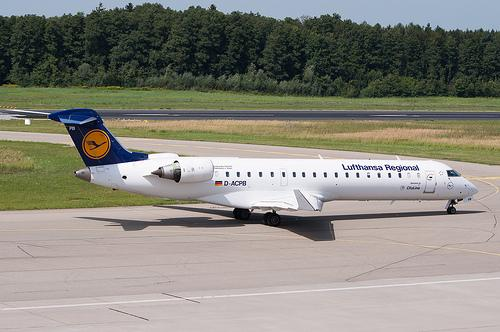Using descriptive language, explain the setting where the main object of the image is situated. An elegant white airplane with a vivid blue tail sits gracefully on a pristine runway, embraced by lush green trees and a verdant grassy field nearby. Mention the main object in the image and describe its most distinctive feature(s). The main object is an airplane, which has a white body and a blue tail, resting on a runway. Using poetic language, describe the image's main element and where it is situated. A sleek white aircraft with a touch of blue on its tail rests on the tarmac, surrounded by a sea of emerald green formed by trees and grass. Briefly describe the situation unfolding in the image using descriptive adjectives. A pristine white airplane with an eye-catching blue tail is parked on a clean, gray runway amidst luscious, green trees and grass. What type of environment is the image set in, and which major object can be seen in this environment? The image is set in an airport environment, with a white airplane with a blue tail as the major object. What is the most notable aspect of the scene captured in the image? The most notable aspect is the white airplane with a blue tail, parked on a runway surrounded by greenery. Identify the central element in the image and briefly describe its appearance. The central element is a white airplane with a blue tail, parked on a runway amidst green scenery. If this image were to be used as a backdrop for a movie scene, describe the scenario that could take place in front of it. Picture this: our adventurous protagonist, about to embark on a thrilling escapade, dashes across the verdant grass to board a gleaming white airplane with a striking blue tail that awaits on the tarmac. In simple words, mention the main object present in the image and where it is located. There is a white airplane with a blue tail on a runway, surrounded by green trees and grass. What are the primary colors seen in the image, and on which objects can they be found? The primary colors are white and blue on the airplane, green on trees and grass, and gray on the runway. 